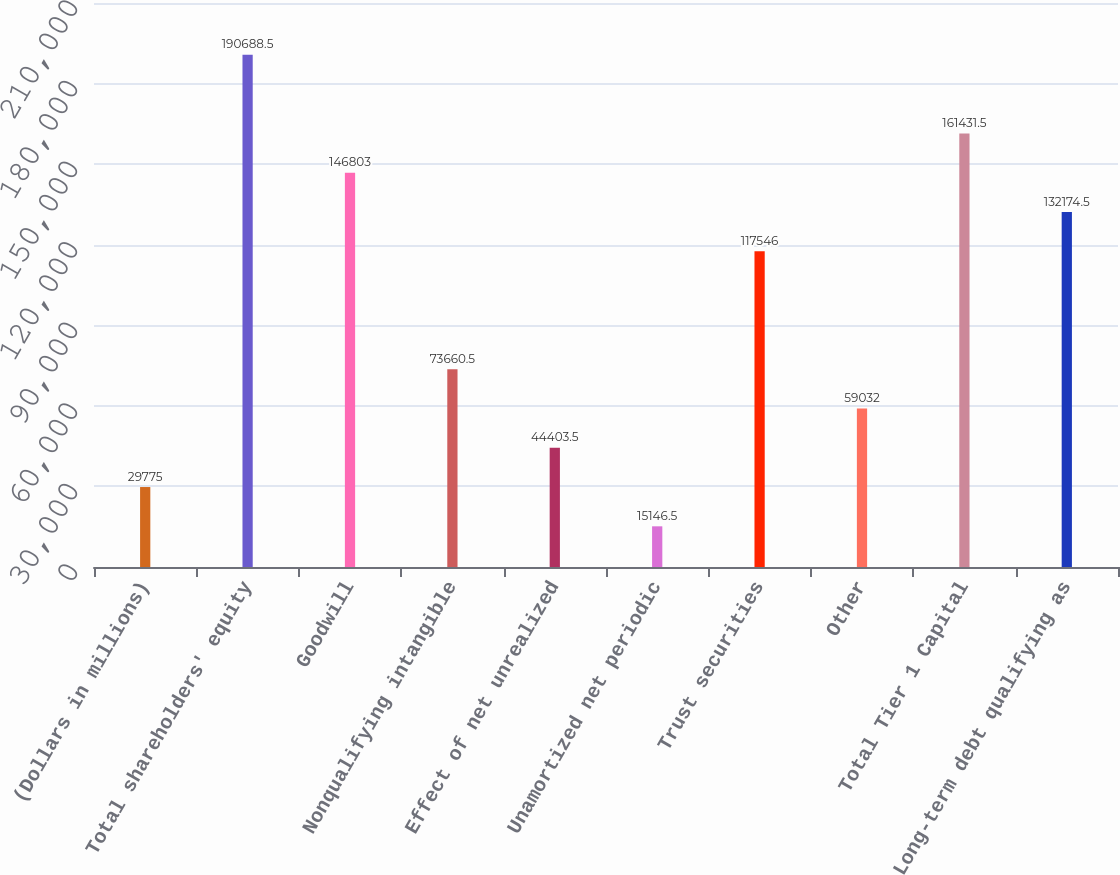<chart> <loc_0><loc_0><loc_500><loc_500><bar_chart><fcel>(Dollars in millions)<fcel>Total shareholders' equity<fcel>Goodwill<fcel>Nonqualifying intangible<fcel>Effect of net unrealized<fcel>Unamortized net periodic<fcel>Trust securities<fcel>Other<fcel>Total Tier 1 Capital<fcel>Long-term debt qualifying as<nl><fcel>29775<fcel>190688<fcel>146803<fcel>73660.5<fcel>44403.5<fcel>15146.5<fcel>117546<fcel>59032<fcel>161432<fcel>132174<nl></chart> 